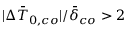<formula> <loc_0><loc_0><loc_500><loc_500>| \Delta \bar { T } _ { 0 , c o } | / \bar { \delta } _ { c o } > 2</formula> 